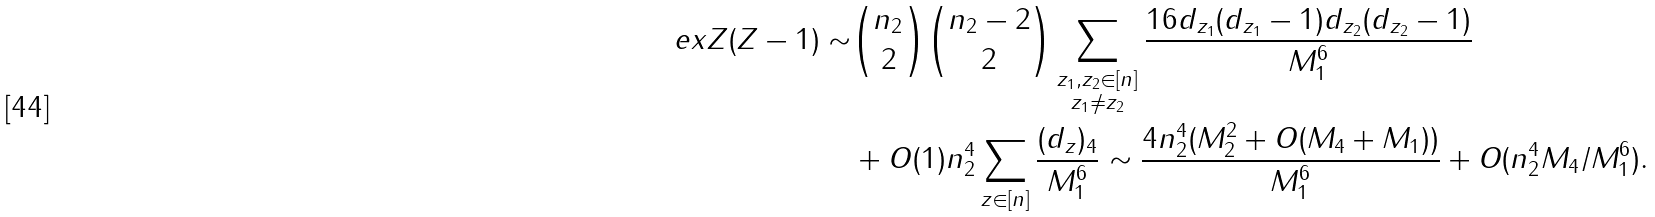<formula> <loc_0><loc_0><loc_500><loc_500>\ e x Z ( Z - 1 ) \sim & { n _ { 2 } \choose 2 } \binom { n _ { 2 } - 2 } { 2 } \sum _ { \substack { z _ { 1 } , z _ { 2 } \in [ n ] \\ z _ { 1 } \neq z _ { 2 } } } \frac { 1 6 d _ { z _ { 1 } } ( d _ { z _ { 1 } } - 1 ) d _ { z _ { 2 } } ( d _ { z _ { 2 } } - 1 ) } { M _ { 1 } ^ { 6 } } \\ & + O ( 1 ) n _ { 2 } ^ { 4 } \sum _ { z \in [ n ] } \frac { ( d _ { z } ) _ { 4 } } { M _ { 1 } ^ { 6 } } \sim \frac { 4 n _ { 2 } ^ { 4 } ( M _ { 2 } ^ { 2 } + O ( M _ { 4 } + M _ { 1 } ) ) } { M _ { 1 } ^ { 6 } } + O ( n _ { 2 } ^ { 4 } M _ { 4 } / M _ { 1 } ^ { 6 } ) .</formula> 